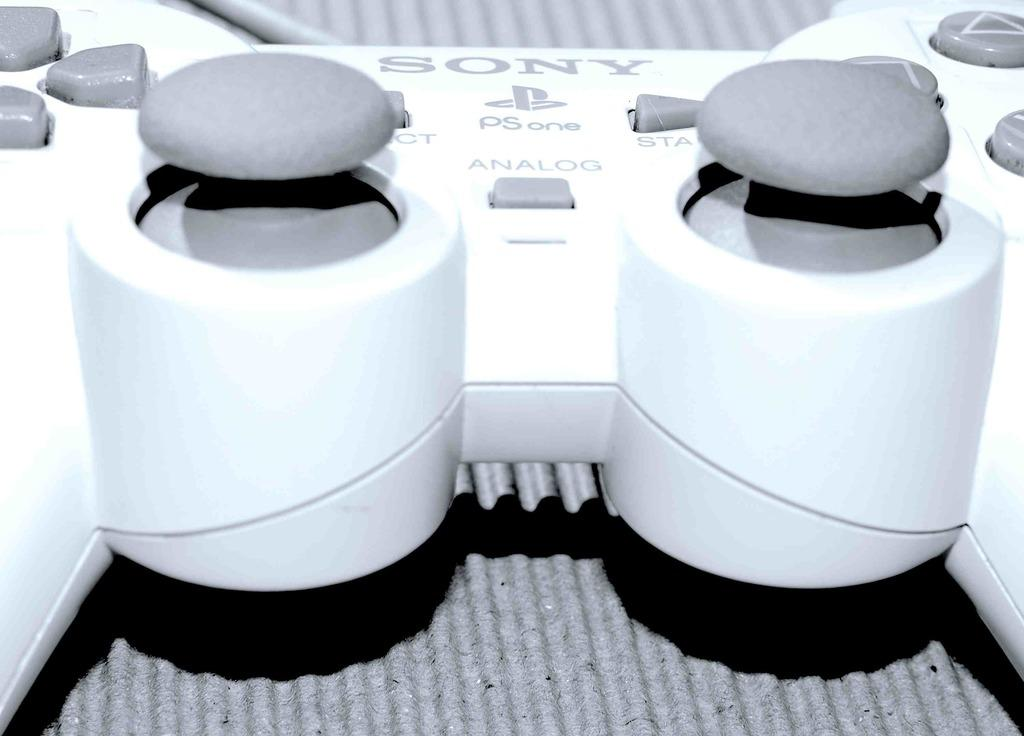What object is the main focus of the image? There is a joystick in the image. What is the joystick placed on or near? There is a surface at the bottom of the image. What type of body is visible in the image? There is no body present in the image; it only features a joystick and a surface. What type of calculator is being used with the joystick in the image? There is no calculator present in the image; it only features a joystick and a surface. 